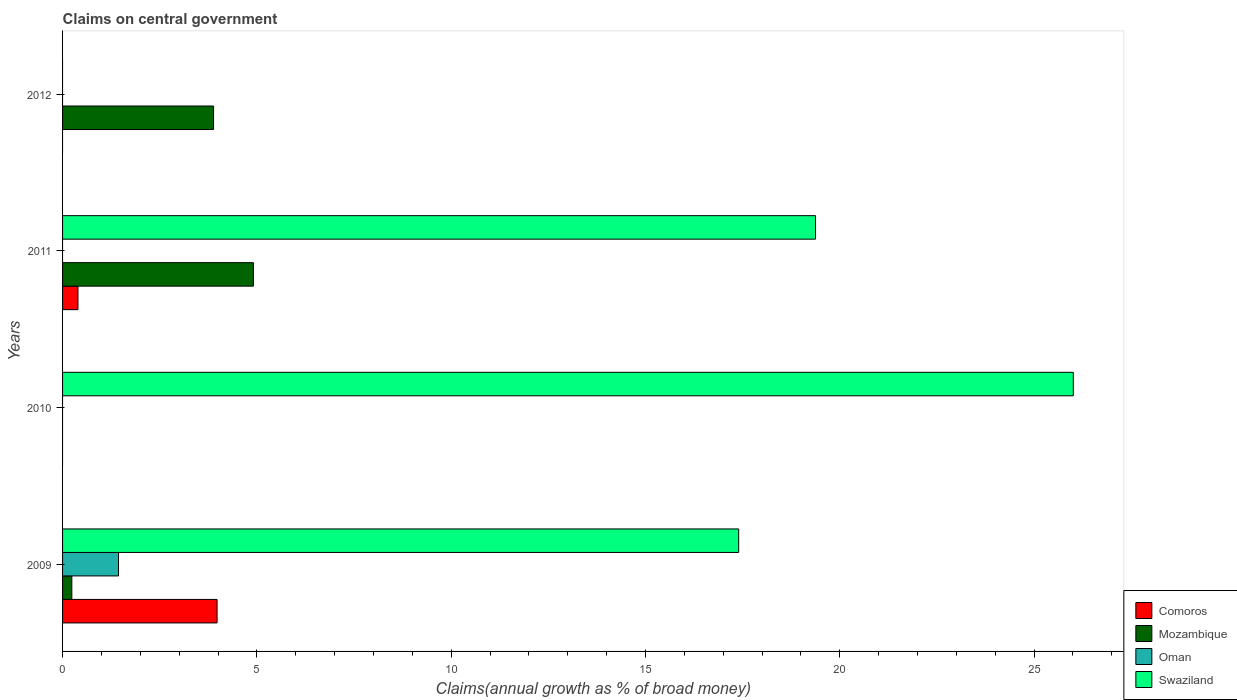Are the number of bars per tick equal to the number of legend labels?
Provide a succinct answer. No. How many bars are there on the 3rd tick from the top?
Your response must be concise. 1. In how many cases, is the number of bars for a given year not equal to the number of legend labels?
Provide a short and direct response. 3. What is the percentage of broad money claimed on centeral government in Swaziland in 2010?
Offer a very short reply. 26.01. Across all years, what is the maximum percentage of broad money claimed on centeral government in Mozambique?
Ensure brevity in your answer.  4.91. Across all years, what is the minimum percentage of broad money claimed on centeral government in Swaziland?
Your response must be concise. 0. In which year was the percentage of broad money claimed on centeral government in Swaziland maximum?
Offer a terse response. 2010. What is the total percentage of broad money claimed on centeral government in Mozambique in the graph?
Your answer should be very brief. 9.04. What is the difference between the percentage of broad money claimed on centeral government in Comoros in 2009 and that in 2011?
Your answer should be very brief. 3.58. What is the difference between the percentage of broad money claimed on centeral government in Mozambique in 2010 and the percentage of broad money claimed on centeral government in Swaziland in 2009?
Offer a very short reply. -17.4. What is the average percentage of broad money claimed on centeral government in Swaziland per year?
Your answer should be compact. 15.7. In the year 2011, what is the difference between the percentage of broad money claimed on centeral government in Comoros and percentage of broad money claimed on centeral government in Swaziland?
Offer a very short reply. -18.98. In how many years, is the percentage of broad money claimed on centeral government in Oman greater than 3 %?
Offer a very short reply. 0. What is the ratio of the percentage of broad money claimed on centeral government in Swaziland in 2009 to that in 2010?
Offer a very short reply. 0.67. Is the difference between the percentage of broad money claimed on centeral government in Comoros in 2009 and 2011 greater than the difference between the percentage of broad money claimed on centeral government in Swaziland in 2009 and 2011?
Offer a terse response. Yes. What is the difference between the highest and the second highest percentage of broad money claimed on centeral government in Swaziland?
Ensure brevity in your answer.  6.63. What is the difference between the highest and the lowest percentage of broad money claimed on centeral government in Comoros?
Keep it short and to the point. 3.98. In how many years, is the percentage of broad money claimed on centeral government in Comoros greater than the average percentage of broad money claimed on centeral government in Comoros taken over all years?
Make the answer very short. 1. Is it the case that in every year, the sum of the percentage of broad money claimed on centeral government in Mozambique and percentage of broad money claimed on centeral government in Oman is greater than the percentage of broad money claimed on centeral government in Comoros?
Give a very brief answer. No. How many bars are there?
Offer a terse response. 9. Are all the bars in the graph horizontal?
Provide a succinct answer. Yes. What is the difference between two consecutive major ticks on the X-axis?
Offer a very short reply. 5. Are the values on the major ticks of X-axis written in scientific E-notation?
Ensure brevity in your answer.  No. How many legend labels are there?
Your answer should be compact. 4. What is the title of the graph?
Offer a terse response. Claims on central government. What is the label or title of the X-axis?
Give a very brief answer. Claims(annual growth as % of broad money). What is the Claims(annual growth as % of broad money) of Comoros in 2009?
Your answer should be very brief. 3.98. What is the Claims(annual growth as % of broad money) in Mozambique in 2009?
Your response must be concise. 0.24. What is the Claims(annual growth as % of broad money) of Oman in 2009?
Offer a very short reply. 1.44. What is the Claims(annual growth as % of broad money) of Swaziland in 2009?
Your answer should be compact. 17.4. What is the Claims(annual growth as % of broad money) in Comoros in 2010?
Your answer should be compact. 0. What is the Claims(annual growth as % of broad money) in Oman in 2010?
Offer a terse response. 0. What is the Claims(annual growth as % of broad money) of Swaziland in 2010?
Keep it short and to the point. 26.01. What is the Claims(annual growth as % of broad money) in Comoros in 2011?
Ensure brevity in your answer.  0.4. What is the Claims(annual growth as % of broad money) of Mozambique in 2011?
Give a very brief answer. 4.91. What is the Claims(annual growth as % of broad money) in Oman in 2011?
Provide a short and direct response. 0. What is the Claims(annual growth as % of broad money) of Swaziland in 2011?
Make the answer very short. 19.38. What is the Claims(annual growth as % of broad money) in Comoros in 2012?
Make the answer very short. 0. What is the Claims(annual growth as % of broad money) of Mozambique in 2012?
Your answer should be very brief. 3.89. Across all years, what is the maximum Claims(annual growth as % of broad money) in Comoros?
Your answer should be very brief. 3.98. Across all years, what is the maximum Claims(annual growth as % of broad money) in Mozambique?
Offer a very short reply. 4.91. Across all years, what is the maximum Claims(annual growth as % of broad money) of Oman?
Your answer should be compact. 1.44. Across all years, what is the maximum Claims(annual growth as % of broad money) of Swaziland?
Keep it short and to the point. 26.01. Across all years, what is the minimum Claims(annual growth as % of broad money) of Mozambique?
Your answer should be compact. 0. Across all years, what is the minimum Claims(annual growth as % of broad money) in Oman?
Make the answer very short. 0. Across all years, what is the minimum Claims(annual growth as % of broad money) in Swaziland?
Provide a succinct answer. 0. What is the total Claims(annual growth as % of broad money) in Comoros in the graph?
Your answer should be compact. 4.37. What is the total Claims(annual growth as % of broad money) in Mozambique in the graph?
Make the answer very short. 9.04. What is the total Claims(annual growth as % of broad money) in Oman in the graph?
Keep it short and to the point. 1.44. What is the total Claims(annual growth as % of broad money) of Swaziland in the graph?
Offer a terse response. 62.79. What is the difference between the Claims(annual growth as % of broad money) of Swaziland in 2009 and that in 2010?
Keep it short and to the point. -8.61. What is the difference between the Claims(annual growth as % of broad money) in Comoros in 2009 and that in 2011?
Make the answer very short. 3.58. What is the difference between the Claims(annual growth as % of broad money) of Mozambique in 2009 and that in 2011?
Ensure brevity in your answer.  -4.67. What is the difference between the Claims(annual growth as % of broad money) in Swaziland in 2009 and that in 2011?
Your response must be concise. -1.98. What is the difference between the Claims(annual growth as % of broad money) of Mozambique in 2009 and that in 2012?
Keep it short and to the point. -3.65. What is the difference between the Claims(annual growth as % of broad money) in Swaziland in 2010 and that in 2011?
Keep it short and to the point. 6.63. What is the difference between the Claims(annual growth as % of broad money) in Mozambique in 2011 and that in 2012?
Ensure brevity in your answer.  1.03. What is the difference between the Claims(annual growth as % of broad money) in Comoros in 2009 and the Claims(annual growth as % of broad money) in Swaziland in 2010?
Your response must be concise. -22.03. What is the difference between the Claims(annual growth as % of broad money) of Mozambique in 2009 and the Claims(annual growth as % of broad money) of Swaziland in 2010?
Your answer should be very brief. -25.77. What is the difference between the Claims(annual growth as % of broad money) of Oman in 2009 and the Claims(annual growth as % of broad money) of Swaziland in 2010?
Ensure brevity in your answer.  -24.57. What is the difference between the Claims(annual growth as % of broad money) in Comoros in 2009 and the Claims(annual growth as % of broad money) in Mozambique in 2011?
Your answer should be very brief. -0.93. What is the difference between the Claims(annual growth as % of broad money) of Comoros in 2009 and the Claims(annual growth as % of broad money) of Swaziland in 2011?
Keep it short and to the point. -15.4. What is the difference between the Claims(annual growth as % of broad money) in Mozambique in 2009 and the Claims(annual growth as % of broad money) in Swaziland in 2011?
Your answer should be compact. -19.14. What is the difference between the Claims(annual growth as % of broad money) in Oman in 2009 and the Claims(annual growth as % of broad money) in Swaziland in 2011?
Give a very brief answer. -17.94. What is the difference between the Claims(annual growth as % of broad money) in Comoros in 2009 and the Claims(annual growth as % of broad money) in Mozambique in 2012?
Your answer should be compact. 0.09. What is the difference between the Claims(annual growth as % of broad money) in Comoros in 2011 and the Claims(annual growth as % of broad money) in Mozambique in 2012?
Give a very brief answer. -3.49. What is the average Claims(annual growth as % of broad money) in Comoros per year?
Your response must be concise. 1.09. What is the average Claims(annual growth as % of broad money) in Mozambique per year?
Your answer should be very brief. 2.26. What is the average Claims(annual growth as % of broad money) of Oman per year?
Your answer should be very brief. 0.36. What is the average Claims(annual growth as % of broad money) of Swaziland per year?
Keep it short and to the point. 15.7. In the year 2009, what is the difference between the Claims(annual growth as % of broad money) of Comoros and Claims(annual growth as % of broad money) of Mozambique?
Give a very brief answer. 3.74. In the year 2009, what is the difference between the Claims(annual growth as % of broad money) of Comoros and Claims(annual growth as % of broad money) of Oman?
Give a very brief answer. 2.54. In the year 2009, what is the difference between the Claims(annual growth as % of broad money) in Comoros and Claims(annual growth as % of broad money) in Swaziland?
Make the answer very short. -13.42. In the year 2009, what is the difference between the Claims(annual growth as % of broad money) of Mozambique and Claims(annual growth as % of broad money) of Oman?
Keep it short and to the point. -1.2. In the year 2009, what is the difference between the Claims(annual growth as % of broad money) of Mozambique and Claims(annual growth as % of broad money) of Swaziland?
Offer a terse response. -17.16. In the year 2009, what is the difference between the Claims(annual growth as % of broad money) of Oman and Claims(annual growth as % of broad money) of Swaziland?
Make the answer very short. -15.96. In the year 2011, what is the difference between the Claims(annual growth as % of broad money) in Comoros and Claims(annual growth as % of broad money) in Mozambique?
Ensure brevity in your answer.  -4.51. In the year 2011, what is the difference between the Claims(annual growth as % of broad money) in Comoros and Claims(annual growth as % of broad money) in Swaziland?
Ensure brevity in your answer.  -18.98. In the year 2011, what is the difference between the Claims(annual growth as % of broad money) of Mozambique and Claims(annual growth as % of broad money) of Swaziland?
Give a very brief answer. -14.47. What is the ratio of the Claims(annual growth as % of broad money) in Swaziland in 2009 to that in 2010?
Ensure brevity in your answer.  0.67. What is the ratio of the Claims(annual growth as % of broad money) in Comoros in 2009 to that in 2011?
Offer a very short reply. 10.03. What is the ratio of the Claims(annual growth as % of broad money) in Mozambique in 2009 to that in 2011?
Offer a very short reply. 0.05. What is the ratio of the Claims(annual growth as % of broad money) in Swaziland in 2009 to that in 2011?
Keep it short and to the point. 0.9. What is the ratio of the Claims(annual growth as % of broad money) of Mozambique in 2009 to that in 2012?
Offer a terse response. 0.06. What is the ratio of the Claims(annual growth as % of broad money) of Swaziland in 2010 to that in 2011?
Your answer should be very brief. 1.34. What is the ratio of the Claims(annual growth as % of broad money) of Mozambique in 2011 to that in 2012?
Provide a short and direct response. 1.26. What is the difference between the highest and the second highest Claims(annual growth as % of broad money) of Mozambique?
Keep it short and to the point. 1.03. What is the difference between the highest and the second highest Claims(annual growth as % of broad money) in Swaziland?
Provide a short and direct response. 6.63. What is the difference between the highest and the lowest Claims(annual growth as % of broad money) in Comoros?
Ensure brevity in your answer.  3.98. What is the difference between the highest and the lowest Claims(annual growth as % of broad money) of Mozambique?
Give a very brief answer. 4.91. What is the difference between the highest and the lowest Claims(annual growth as % of broad money) of Oman?
Ensure brevity in your answer.  1.44. What is the difference between the highest and the lowest Claims(annual growth as % of broad money) in Swaziland?
Provide a succinct answer. 26.01. 